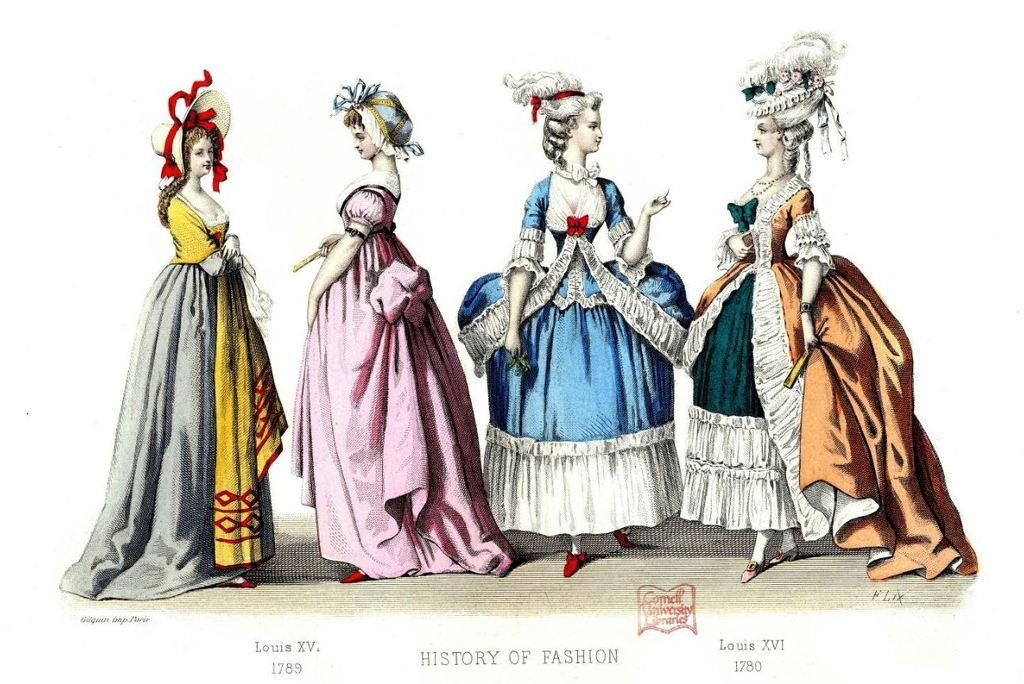What is present in the image that features multiple women? There is a poster in the image that contains pictures of four women. What are the women wearing in the poster? The women are wearing long frocks in the poster. Is there any text on the poster? Yes, there is text at the bottom of the poster. What type of pie is being served by the woman on the left side of the poster? There is no pie present in the image; it features a poster with pictures of four women wearing long frocks and text at the bottom. 